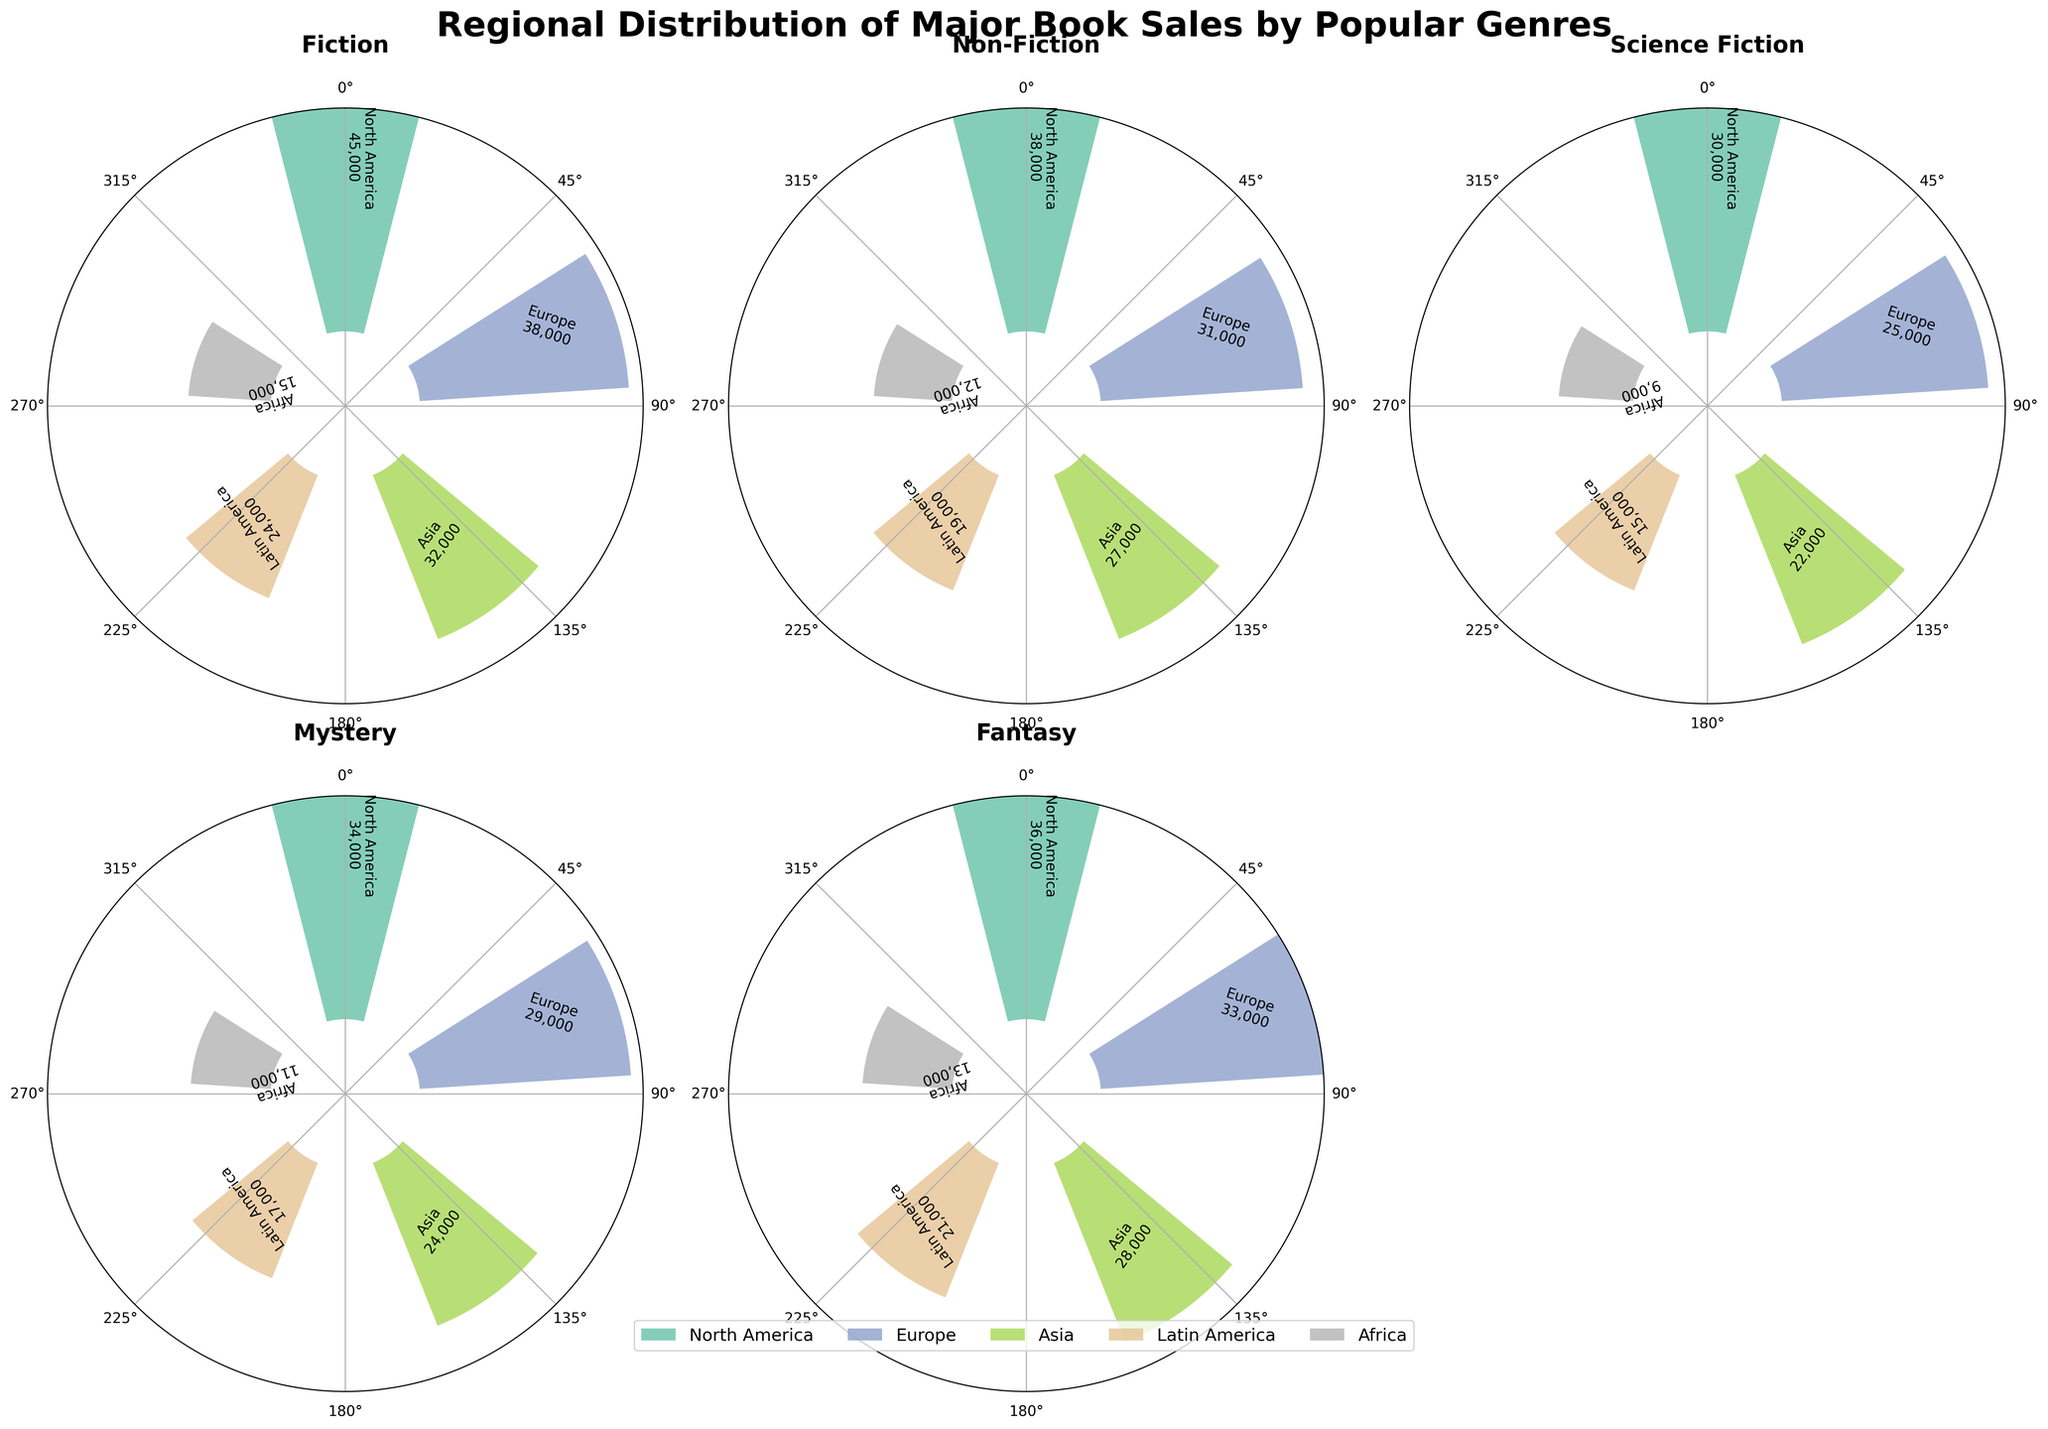What is the title of the figure? The title is typically found at the top of the figure. In this case, it reads "Regional Distribution of Major Book Sales by Popular Genres".
Answer: Regional Distribution of Major Book Sales by Popular Genres How many regions are represented in each subplot? By looking at each subplot, we observe that there are distinct color-coded sections annotated with region names. Counting the unique regions, we see there are five: North America, Europe, Asia, Latin America, and Africa.
Answer: 5 What genre has the highest sales in North America? Find the North American section for each genre and compare the heights of the corresponding bars. Fiction has the tallest bar for North America with sales of 45,000.
Answer: Fiction What is the total sales for Fiction across all regions? Sum the sales from all regions in the Fiction subplot: 45,000 (North America) + 38,000 (Europe) + 32,000 (Asia) + 24,000 (Latin America) + 15,000 (Africa) = 154,000.
Answer: 154,000 How do the Non-Fiction sales in Europe compare to those in Asia? Compare the heights of the bars for Non-Fiction in Europe and Asia. Non-Fiction sales in Europe are 31,000 and in Asia are 27,000. Europe has higher sales.
Answer: Europe has higher sales Which genre has the lowest sales value in Africa? Identify the smallest bar within the Africa section across all genres. Science Fiction has the lowest sales with 9,000 in Africa.
Answer: Science Fiction What is the difference in sales between Science Fiction in North America and Latin America? Subtract the Latin America sales from North America sales for Science Fiction: 30,000 (North America) - 15,000 (Latin America) = 15,000.
Answer: 15,000 Which genre has the most balanced distribution of sales across all regions? Observe the uniformity of the bar heights across regions for each genre. Non-Fiction has relatively even heights across all regions compared to other genres.
Answer: Non-Fiction What is the average sales value for Fantasy across the five regions? Sum the sales of Fantasy across all regions and divide by five: (36,000 + 33,000 + 28,000 + 21,000 + 13,000) / 5 = 131,000 / 5 = 26,200.
Answer: 26,200 What are the two regions with the highest combined sales for Mystery? Sum the sales for Mystery across the regions, and find the two highest sums: 34,000 (North America) + 29,000 (Europe) = 63,000; 34,000 (North America) + 24,000 (Asia) = 58,000; other combinations result in lower sums.
Answer: North America and Europe 